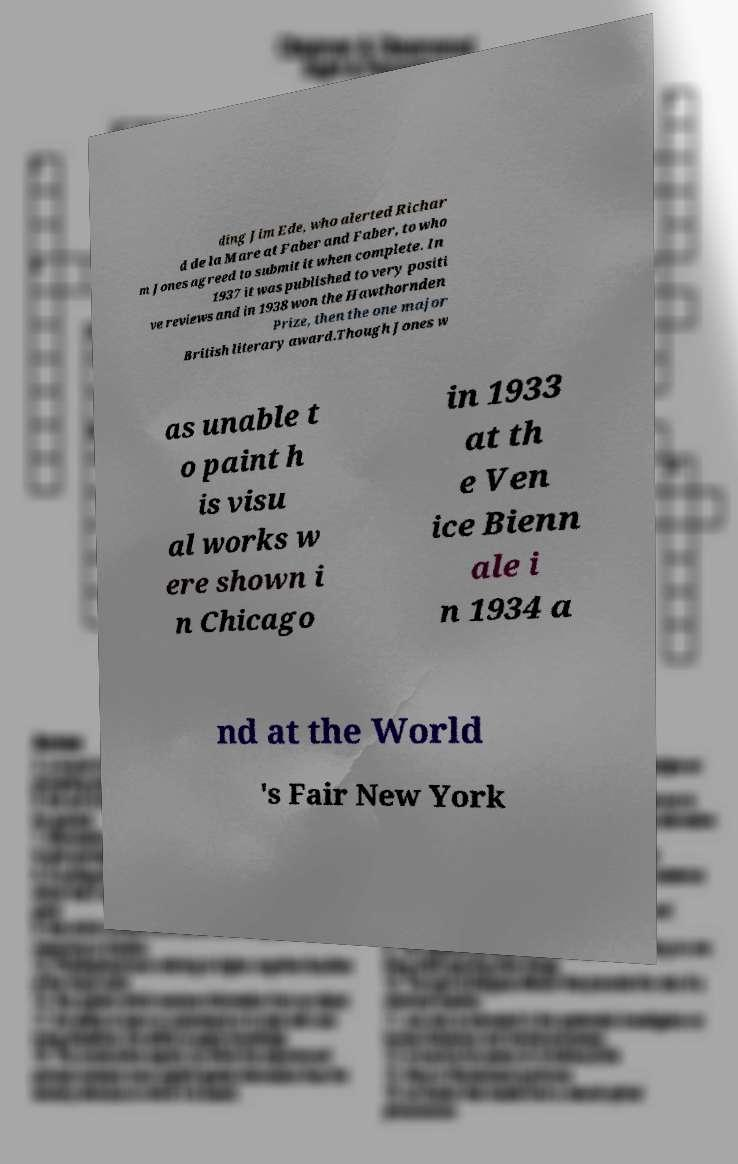Please read and relay the text visible in this image. What does it say? ding Jim Ede, who alerted Richar d de la Mare at Faber and Faber, to who m Jones agreed to submit it when complete. In 1937 it was published to very positi ve reviews and in 1938 won the Hawthornden Prize, then the one major British literary award.Though Jones w as unable t o paint h is visu al works w ere shown i n Chicago in 1933 at th e Ven ice Bienn ale i n 1934 a nd at the World 's Fair New York 